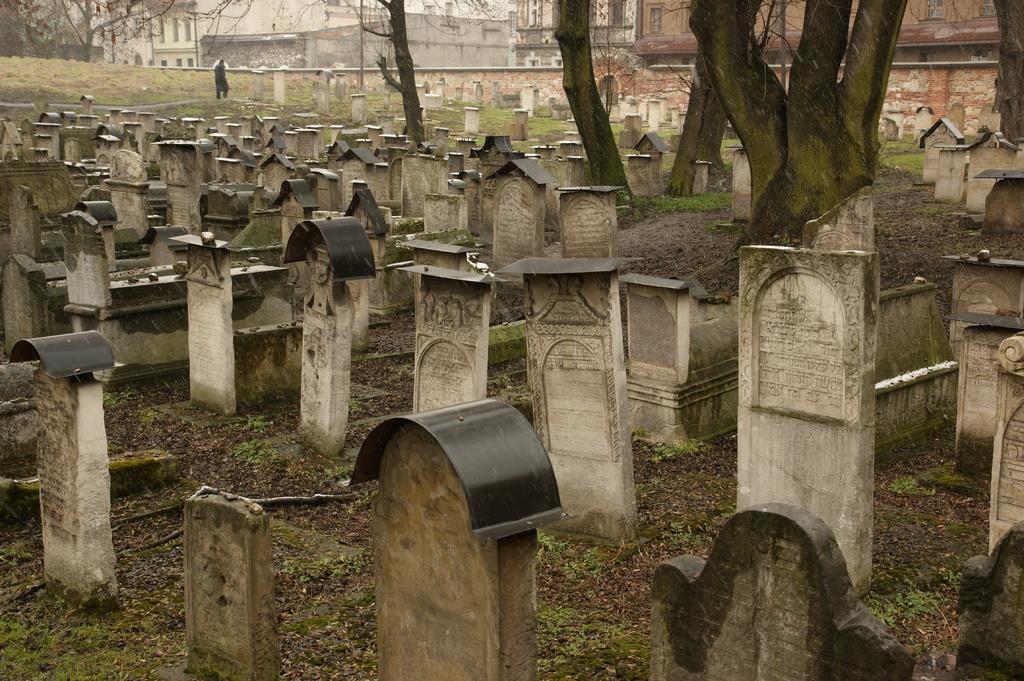In one or two sentences, can you explain what this image depicts? In this picture I can see many graves. In the background I can see the buildings, poles and trees. At the top I can see the sky. In the top left there is a man who is standing near to the grave. At the bottom I can see some grass. 